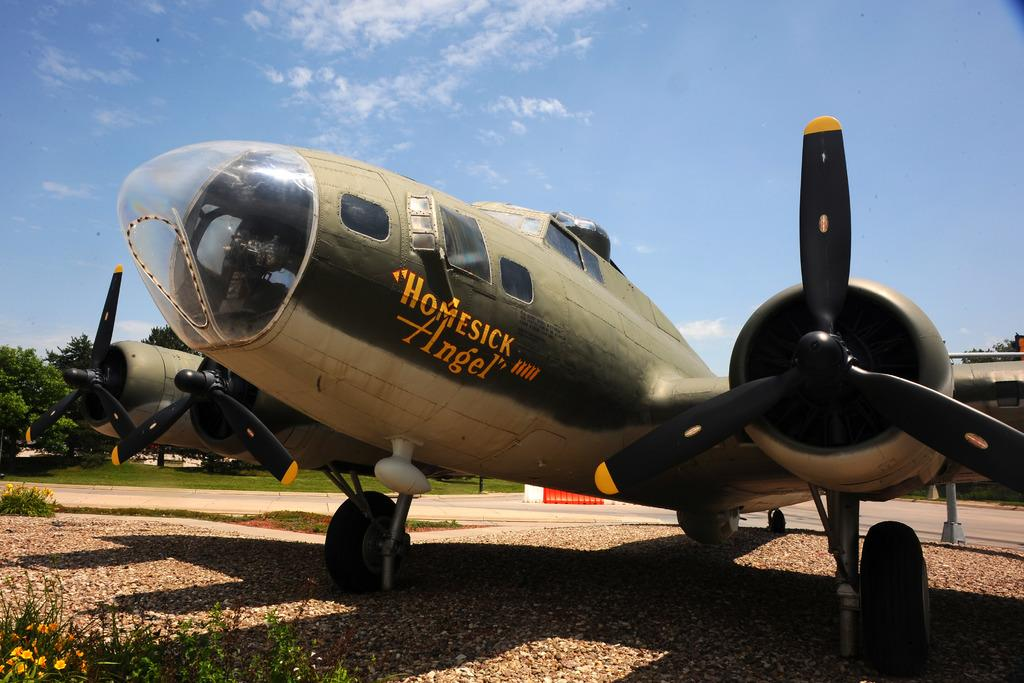<image>
Offer a succinct explanation of the picture presented. a propeller plane, the homesick angel is sitting on a gravel area 